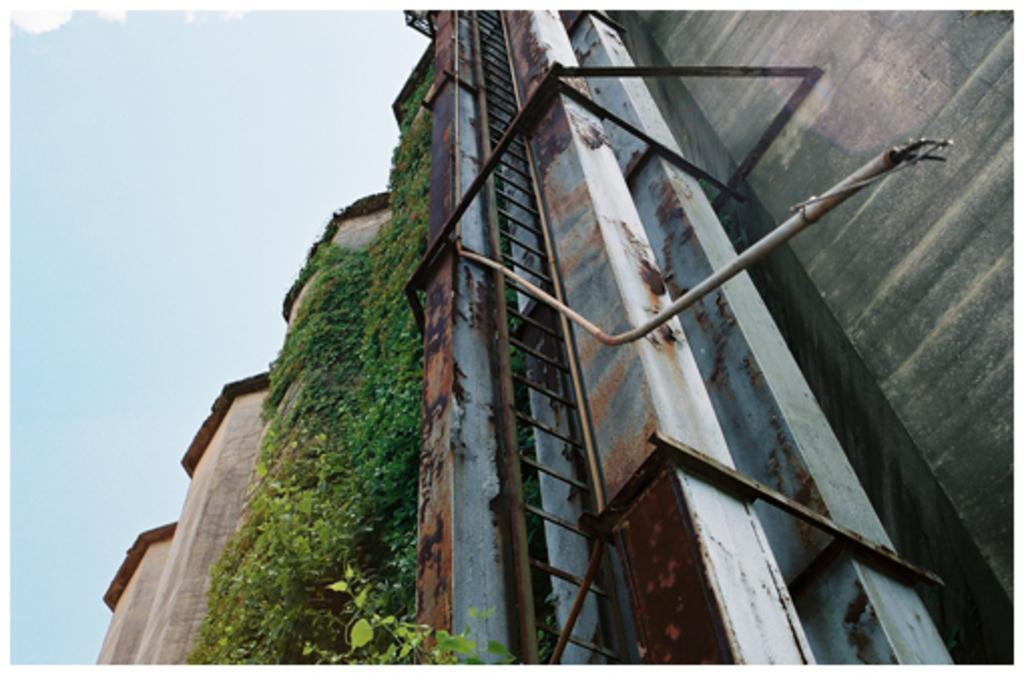How would you summarize this image in a sentence or two? In this image we can see the building wall with creepers and also rusted rods. We can also see the plant at the bottom. Sky is also visible in this image. 